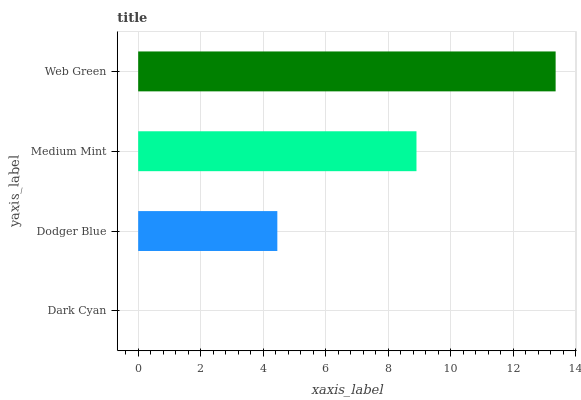Is Dark Cyan the minimum?
Answer yes or no. Yes. Is Web Green the maximum?
Answer yes or no. Yes. Is Dodger Blue the minimum?
Answer yes or no. No. Is Dodger Blue the maximum?
Answer yes or no. No. Is Dodger Blue greater than Dark Cyan?
Answer yes or no. Yes. Is Dark Cyan less than Dodger Blue?
Answer yes or no. Yes. Is Dark Cyan greater than Dodger Blue?
Answer yes or no. No. Is Dodger Blue less than Dark Cyan?
Answer yes or no. No. Is Medium Mint the high median?
Answer yes or no. Yes. Is Dodger Blue the low median?
Answer yes or no. Yes. Is Dark Cyan the high median?
Answer yes or no. No. Is Web Green the low median?
Answer yes or no. No. 